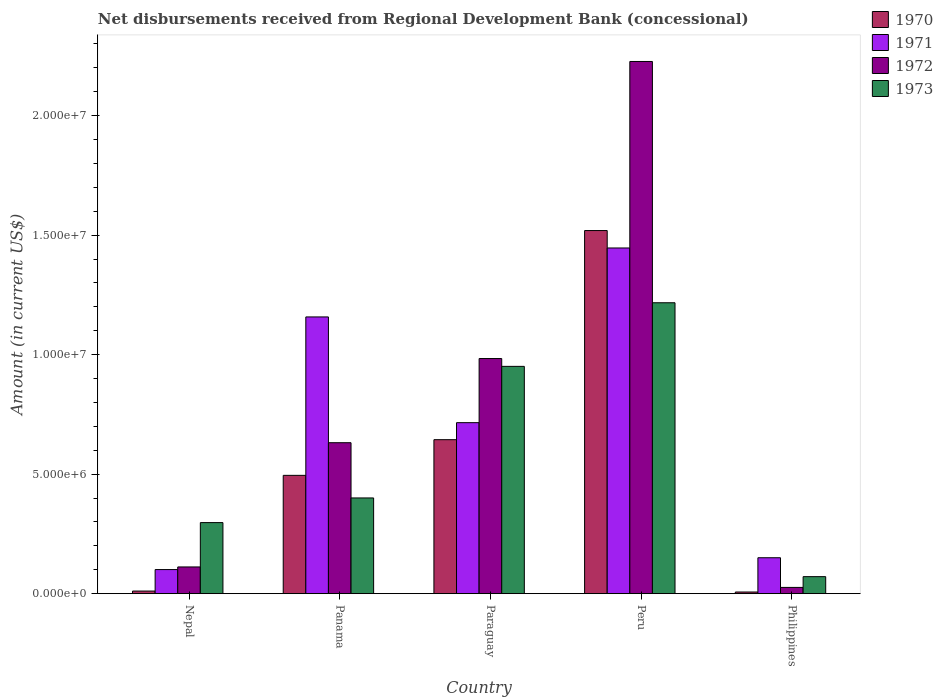Are the number of bars per tick equal to the number of legend labels?
Offer a terse response. Yes. Are the number of bars on each tick of the X-axis equal?
Offer a very short reply. Yes. What is the label of the 4th group of bars from the left?
Your answer should be compact. Peru. In how many cases, is the number of bars for a given country not equal to the number of legend labels?
Your response must be concise. 0. What is the amount of disbursements received from Regional Development Bank in 1972 in Peru?
Your answer should be compact. 2.23e+07. Across all countries, what is the maximum amount of disbursements received from Regional Development Bank in 1973?
Your answer should be compact. 1.22e+07. Across all countries, what is the minimum amount of disbursements received from Regional Development Bank in 1972?
Provide a succinct answer. 2.61e+05. In which country was the amount of disbursements received from Regional Development Bank in 1971 minimum?
Your answer should be compact. Nepal. What is the total amount of disbursements received from Regional Development Bank in 1971 in the graph?
Provide a succinct answer. 3.57e+07. What is the difference between the amount of disbursements received from Regional Development Bank in 1971 in Panama and that in Paraguay?
Keep it short and to the point. 4.42e+06. What is the difference between the amount of disbursements received from Regional Development Bank in 1973 in Philippines and the amount of disbursements received from Regional Development Bank in 1972 in Nepal?
Give a very brief answer. -4.06e+05. What is the average amount of disbursements received from Regional Development Bank in 1972 per country?
Offer a terse response. 7.96e+06. What is the difference between the amount of disbursements received from Regional Development Bank of/in 1972 and amount of disbursements received from Regional Development Bank of/in 1970 in Nepal?
Your response must be concise. 1.01e+06. What is the ratio of the amount of disbursements received from Regional Development Bank in 1972 in Nepal to that in Panama?
Provide a short and direct response. 0.18. Is the amount of disbursements received from Regional Development Bank in 1972 in Paraguay less than that in Philippines?
Provide a succinct answer. No. What is the difference between the highest and the second highest amount of disbursements received from Regional Development Bank in 1973?
Make the answer very short. 2.66e+06. What is the difference between the highest and the lowest amount of disbursements received from Regional Development Bank in 1972?
Your answer should be very brief. 2.20e+07. In how many countries, is the amount of disbursements received from Regional Development Bank in 1970 greater than the average amount of disbursements received from Regional Development Bank in 1970 taken over all countries?
Provide a short and direct response. 2. Is the sum of the amount of disbursements received from Regional Development Bank in 1971 in Peru and Philippines greater than the maximum amount of disbursements received from Regional Development Bank in 1972 across all countries?
Offer a very short reply. No. Is it the case that in every country, the sum of the amount of disbursements received from Regional Development Bank in 1973 and amount of disbursements received from Regional Development Bank in 1972 is greater than the amount of disbursements received from Regional Development Bank in 1971?
Keep it short and to the point. No. How many bars are there?
Offer a very short reply. 20. How many countries are there in the graph?
Give a very brief answer. 5. What is the difference between two consecutive major ticks on the Y-axis?
Your response must be concise. 5.00e+06. Are the values on the major ticks of Y-axis written in scientific E-notation?
Ensure brevity in your answer.  Yes. Does the graph contain any zero values?
Offer a very short reply. No. Does the graph contain grids?
Make the answer very short. No. What is the title of the graph?
Give a very brief answer. Net disbursements received from Regional Development Bank (concessional). What is the Amount (in current US$) of 1970 in Nepal?
Give a very brief answer. 1.09e+05. What is the Amount (in current US$) in 1971 in Nepal?
Your answer should be compact. 1.01e+06. What is the Amount (in current US$) in 1972 in Nepal?
Ensure brevity in your answer.  1.12e+06. What is the Amount (in current US$) in 1973 in Nepal?
Your answer should be compact. 2.97e+06. What is the Amount (in current US$) in 1970 in Panama?
Your response must be concise. 4.95e+06. What is the Amount (in current US$) of 1971 in Panama?
Offer a terse response. 1.16e+07. What is the Amount (in current US$) in 1972 in Panama?
Offer a terse response. 6.32e+06. What is the Amount (in current US$) of 1973 in Panama?
Offer a terse response. 4.00e+06. What is the Amount (in current US$) in 1970 in Paraguay?
Your answer should be very brief. 6.44e+06. What is the Amount (in current US$) in 1971 in Paraguay?
Provide a short and direct response. 7.16e+06. What is the Amount (in current US$) of 1972 in Paraguay?
Ensure brevity in your answer.  9.84e+06. What is the Amount (in current US$) of 1973 in Paraguay?
Offer a very short reply. 9.51e+06. What is the Amount (in current US$) in 1970 in Peru?
Give a very brief answer. 1.52e+07. What is the Amount (in current US$) in 1971 in Peru?
Your answer should be very brief. 1.45e+07. What is the Amount (in current US$) in 1972 in Peru?
Provide a short and direct response. 2.23e+07. What is the Amount (in current US$) in 1973 in Peru?
Keep it short and to the point. 1.22e+07. What is the Amount (in current US$) of 1970 in Philippines?
Keep it short and to the point. 6.90e+04. What is the Amount (in current US$) in 1971 in Philippines?
Provide a succinct answer. 1.50e+06. What is the Amount (in current US$) of 1972 in Philippines?
Ensure brevity in your answer.  2.61e+05. What is the Amount (in current US$) of 1973 in Philippines?
Your response must be concise. 7.12e+05. Across all countries, what is the maximum Amount (in current US$) of 1970?
Your response must be concise. 1.52e+07. Across all countries, what is the maximum Amount (in current US$) in 1971?
Keep it short and to the point. 1.45e+07. Across all countries, what is the maximum Amount (in current US$) in 1972?
Offer a terse response. 2.23e+07. Across all countries, what is the maximum Amount (in current US$) in 1973?
Provide a succinct answer. 1.22e+07. Across all countries, what is the minimum Amount (in current US$) in 1970?
Your response must be concise. 6.90e+04. Across all countries, what is the minimum Amount (in current US$) in 1971?
Your answer should be very brief. 1.01e+06. Across all countries, what is the minimum Amount (in current US$) of 1972?
Your answer should be compact. 2.61e+05. Across all countries, what is the minimum Amount (in current US$) of 1973?
Keep it short and to the point. 7.12e+05. What is the total Amount (in current US$) in 1970 in the graph?
Provide a succinct answer. 2.68e+07. What is the total Amount (in current US$) in 1971 in the graph?
Provide a short and direct response. 3.57e+07. What is the total Amount (in current US$) in 1972 in the graph?
Keep it short and to the point. 3.98e+07. What is the total Amount (in current US$) of 1973 in the graph?
Provide a succinct answer. 2.94e+07. What is the difference between the Amount (in current US$) of 1970 in Nepal and that in Panama?
Your answer should be compact. -4.84e+06. What is the difference between the Amount (in current US$) of 1971 in Nepal and that in Panama?
Provide a short and direct response. -1.06e+07. What is the difference between the Amount (in current US$) of 1972 in Nepal and that in Panama?
Offer a very short reply. -5.20e+06. What is the difference between the Amount (in current US$) in 1973 in Nepal and that in Panama?
Give a very brief answer. -1.03e+06. What is the difference between the Amount (in current US$) of 1970 in Nepal and that in Paraguay?
Your answer should be very brief. -6.33e+06. What is the difference between the Amount (in current US$) in 1971 in Nepal and that in Paraguay?
Provide a short and direct response. -6.15e+06. What is the difference between the Amount (in current US$) of 1972 in Nepal and that in Paraguay?
Offer a terse response. -8.72e+06. What is the difference between the Amount (in current US$) of 1973 in Nepal and that in Paraguay?
Provide a succinct answer. -6.54e+06. What is the difference between the Amount (in current US$) of 1970 in Nepal and that in Peru?
Provide a succinct answer. -1.51e+07. What is the difference between the Amount (in current US$) of 1971 in Nepal and that in Peru?
Your response must be concise. -1.35e+07. What is the difference between the Amount (in current US$) in 1972 in Nepal and that in Peru?
Your answer should be compact. -2.11e+07. What is the difference between the Amount (in current US$) of 1973 in Nepal and that in Peru?
Provide a succinct answer. -9.20e+06. What is the difference between the Amount (in current US$) of 1970 in Nepal and that in Philippines?
Your answer should be very brief. 4.00e+04. What is the difference between the Amount (in current US$) in 1971 in Nepal and that in Philippines?
Provide a short and direct response. -4.95e+05. What is the difference between the Amount (in current US$) in 1972 in Nepal and that in Philippines?
Your answer should be very brief. 8.57e+05. What is the difference between the Amount (in current US$) of 1973 in Nepal and that in Philippines?
Keep it short and to the point. 2.26e+06. What is the difference between the Amount (in current US$) of 1970 in Panama and that in Paraguay?
Your answer should be compact. -1.49e+06. What is the difference between the Amount (in current US$) in 1971 in Panama and that in Paraguay?
Keep it short and to the point. 4.42e+06. What is the difference between the Amount (in current US$) of 1972 in Panama and that in Paraguay?
Your response must be concise. -3.52e+06. What is the difference between the Amount (in current US$) of 1973 in Panama and that in Paraguay?
Keep it short and to the point. -5.50e+06. What is the difference between the Amount (in current US$) of 1970 in Panama and that in Peru?
Offer a very short reply. -1.02e+07. What is the difference between the Amount (in current US$) of 1971 in Panama and that in Peru?
Give a very brief answer. -2.88e+06. What is the difference between the Amount (in current US$) in 1972 in Panama and that in Peru?
Your response must be concise. -1.60e+07. What is the difference between the Amount (in current US$) of 1973 in Panama and that in Peru?
Your answer should be very brief. -8.17e+06. What is the difference between the Amount (in current US$) in 1970 in Panama and that in Philippines?
Provide a short and direct response. 4.88e+06. What is the difference between the Amount (in current US$) in 1971 in Panama and that in Philippines?
Give a very brief answer. 1.01e+07. What is the difference between the Amount (in current US$) in 1972 in Panama and that in Philippines?
Offer a terse response. 6.06e+06. What is the difference between the Amount (in current US$) in 1973 in Panama and that in Philippines?
Your response must be concise. 3.29e+06. What is the difference between the Amount (in current US$) of 1970 in Paraguay and that in Peru?
Ensure brevity in your answer.  -8.75e+06. What is the difference between the Amount (in current US$) of 1971 in Paraguay and that in Peru?
Offer a terse response. -7.31e+06. What is the difference between the Amount (in current US$) of 1972 in Paraguay and that in Peru?
Make the answer very short. -1.24e+07. What is the difference between the Amount (in current US$) in 1973 in Paraguay and that in Peru?
Keep it short and to the point. -2.66e+06. What is the difference between the Amount (in current US$) of 1970 in Paraguay and that in Philippines?
Your response must be concise. 6.37e+06. What is the difference between the Amount (in current US$) of 1971 in Paraguay and that in Philippines?
Provide a short and direct response. 5.65e+06. What is the difference between the Amount (in current US$) of 1972 in Paraguay and that in Philippines?
Provide a succinct answer. 9.58e+06. What is the difference between the Amount (in current US$) in 1973 in Paraguay and that in Philippines?
Your answer should be very brief. 8.80e+06. What is the difference between the Amount (in current US$) of 1970 in Peru and that in Philippines?
Ensure brevity in your answer.  1.51e+07. What is the difference between the Amount (in current US$) in 1971 in Peru and that in Philippines?
Provide a short and direct response. 1.30e+07. What is the difference between the Amount (in current US$) of 1972 in Peru and that in Philippines?
Make the answer very short. 2.20e+07. What is the difference between the Amount (in current US$) in 1973 in Peru and that in Philippines?
Your answer should be very brief. 1.15e+07. What is the difference between the Amount (in current US$) in 1970 in Nepal and the Amount (in current US$) in 1971 in Panama?
Give a very brief answer. -1.15e+07. What is the difference between the Amount (in current US$) in 1970 in Nepal and the Amount (in current US$) in 1972 in Panama?
Your answer should be compact. -6.21e+06. What is the difference between the Amount (in current US$) in 1970 in Nepal and the Amount (in current US$) in 1973 in Panama?
Your answer should be compact. -3.90e+06. What is the difference between the Amount (in current US$) of 1971 in Nepal and the Amount (in current US$) of 1972 in Panama?
Give a very brief answer. -5.31e+06. What is the difference between the Amount (in current US$) in 1971 in Nepal and the Amount (in current US$) in 1973 in Panama?
Ensure brevity in your answer.  -3.00e+06. What is the difference between the Amount (in current US$) of 1972 in Nepal and the Amount (in current US$) of 1973 in Panama?
Give a very brief answer. -2.89e+06. What is the difference between the Amount (in current US$) of 1970 in Nepal and the Amount (in current US$) of 1971 in Paraguay?
Offer a very short reply. -7.05e+06. What is the difference between the Amount (in current US$) of 1970 in Nepal and the Amount (in current US$) of 1972 in Paraguay?
Provide a short and direct response. -9.73e+06. What is the difference between the Amount (in current US$) in 1970 in Nepal and the Amount (in current US$) in 1973 in Paraguay?
Your answer should be compact. -9.40e+06. What is the difference between the Amount (in current US$) in 1971 in Nepal and the Amount (in current US$) in 1972 in Paraguay?
Keep it short and to the point. -8.83e+06. What is the difference between the Amount (in current US$) of 1971 in Nepal and the Amount (in current US$) of 1973 in Paraguay?
Your answer should be very brief. -8.50e+06. What is the difference between the Amount (in current US$) in 1972 in Nepal and the Amount (in current US$) in 1973 in Paraguay?
Offer a very short reply. -8.39e+06. What is the difference between the Amount (in current US$) in 1970 in Nepal and the Amount (in current US$) in 1971 in Peru?
Provide a short and direct response. -1.44e+07. What is the difference between the Amount (in current US$) in 1970 in Nepal and the Amount (in current US$) in 1972 in Peru?
Your answer should be very brief. -2.22e+07. What is the difference between the Amount (in current US$) in 1970 in Nepal and the Amount (in current US$) in 1973 in Peru?
Make the answer very short. -1.21e+07. What is the difference between the Amount (in current US$) of 1971 in Nepal and the Amount (in current US$) of 1972 in Peru?
Ensure brevity in your answer.  -2.13e+07. What is the difference between the Amount (in current US$) of 1971 in Nepal and the Amount (in current US$) of 1973 in Peru?
Ensure brevity in your answer.  -1.12e+07. What is the difference between the Amount (in current US$) in 1972 in Nepal and the Amount (in current US$) in 1973 in Peru?
Your response must be concise. -1.11e+07. What is the difference between the Amount (in current US$) of 1970 in Nepal and the Amount (in current US$) of 1971 in Philippines?
Your response must be concise. -1.39e+06. What is the difference between the Amount (in current US$) of 1970 in Nepal and the Amount (in current US$) of 1972 in Philippines?
Keep it short and to the point. -1.52e+05. What is the difference between the Amount (in current US$) in 1970 in Nepal and the Amount (in current US$) in 1973 in Philippines?
Keep it short and to the point. -6.03e+05. What is the difference between the Amount (in current US$) in 1971 in Nepal and the Amount (in current US$) in 1972 in Philippines?
Give a very brief answer. 7.47e+05. What is the difference between the Amount (in current US$) in 1971 in Nepal and the Amount (in current US$) in 1973 in Philippines?
Offer a very short reply. 2.96e+05. What is the difference between the Amount (in current US$) in 1972 in Nepal and the Amount (in current US$) in 1973 in Philippines?
Your response must be concise. 4.06e+05. What is the difference between the Amount (in current US$) in 1970 in Panama and the Amount (in current US$) in 1971 in Paraguay?
Give a very brief answer. -2.20e+06. What is the difference between the Amount (in current US$) in 1970 in Panama and the Amount (in current US$) in 1972 in Paraguay?
Your response must be concise. -4.89e+06. What is the difference between the Amount (in current US$) in 1970 in Panama and the Amount (in current US$) in 1973 in Paraguay?
Offer a very short reply. -4.56e+06. What is the difference between the Amount (in current US$) in 1971 in Panama and the Amount (in current US$) in 1972 in Paraguay?
Your answer should be compact. 1.74e+06. What is the difference between the Amount (in current US$) in 1971 in Panama and the Amount (in current US$) in 1973 in Paraguay?
Offer a terse response. 2.07e+06. What is the difference between the Amount (in current US$) of 1972 in Panama and the Amount (in current US$) of 1973 in Paraguay?
Offer a very short reply. -3.19e+06. What is the difference between the Amount (in current US$) in 1970 in Panama and the Amount (in current US$) in 1971 in Peru?
Provide a succinct answer. -9.51e+06. What is the difference between the Amount (in current US$) in 1970 in Panama and the Amount (in current US$) in 1972 in Peru?
Your answer should be compact. -1.73e+07. What is the difference between the Amount (in current US$) of 1970 in Panama and the Amount (in current US$) of 1973 in Peru?
Make the answer very short. -7.22e+06. What is the difference between the Amount (in current US$) of 1971 in Panama and the Amount (in current US$) of 1972 in Peru?
Make the answer very short. -1.07e+07. What is the difference between the Amount (in current US$) of 1971 in Panama and the Amount (in current US$) of 1973 in Peru?
Your answer should be compact. -5.93e+05. What is the difference between the Amount (in current US$) in 1972 in Panama and the Amount (in current US$) in 1973 in Peru?
Keep it short and to the point. -5.86e+06. What is the difference between the Amount (in current US$) of 1970 in Panama and the Amount (in current US$) of 1971 in Philippines?
Give a very brief answer. 3.45e+06. What is the difference between the Amount (in current US$) in 1970 in Panama and the Amount (in current US$) in 1972 in Philippines?
Give a very brief answer. 4.69e+06. What is the difference between the Amount (in current US$) in 1970 in Panama and the Amount (in current US$) in 1973 in Philippines?
Offer a very short reply. 4.24e+06. What is the difference between the Amount (in current US$) of 1971 in Panama and the Amount (in current US$) of 1972 in Philippines?
Keep it short and to the point. 1.13e+07. What is the difference between the Amount (in current US$) in 1971 in Panama and the Amount (in current US$) in 1973 in Philippines?
Ensure brevity in your answer.  1.09e+07. What is the difference between the Amount (in current US$) in 1972 in Panama and the Amount (in current US$) in 1973 in Philippines?
Give a very brief answer. 5.60e+06. What is the difference between the Amount (in current US$) of 1970 in Paraguay and the Amount (in current US$) of 1971 in Peru?
Provide a short and direct response. -8.02e+06. What is the difference between the Amount (in current US$) in 1970 in Paraguay and the Amount (in current US$) in 1972 in Peru?
Keep it short and to the point. -1.58e+07. What is the difference between the Amount (in current US$) in 1970 in Paraguay and the Amount (in current US$) in 1973 in Peru?
Your answer should be compact. -5.73e+06. What is the difference between the Amount (in current US$) of 1971 in Paraguay and the Amount (in current US$) of 1972 in Peru?
Keep it short and to the point. -1.51e+07. What is the difference between the Amount (in current US$) in 1971 in Paraguay and the Amount (in current US$) in 1973 in Peru?
Your answer should be compact. -5.02e+06. What is the difference between the Amount (in current US$) of 1972 in Paraguay and the Amount (in current US$) of 1973 in Peru?
Keep it short and to the point. -2.33e+06. What is the difference between the Amount (in current US$) in 1970 in Paraguay and the Amount (in current US$) in 1971 in Philippines?
Give a very brief answer. 4.94e+06. What is the difference between the Amount (in current US$) of 1970 in Paraguay and the Amount (in current US$) of 1972 in Philippines?
Give a very brief answer. 6.18e+06. What is the difference between the Amount (in current US$) of 1970 in Paraguay and the Amount (in current US$) of 1973 in Philippines?
Your response must be concise. 5.73e+06. What is the difference between the Amount (in current US$) of 1971 in Paraguay and the Amount (in current US$) of 1972 in Philippines?
Ensure brevity in your answer.  6.89e+06. What is the difference between the Amount (in current US$) in 1971 in Paraguay and the Amount (in current US$) in 1973 in Philippines?
Give a very brief answer. 6.44e+06. What is the difference between the Amount (in current US$) of 1972 in Paraguay and the Amount (in current US$) of 1973 in Philippines?
Ensure brevity in your answer.  9.13e+06. What is the difference between the Amount (in current US$) of 1970 in Peru and the Amount (in current US$) of 1971 in Philippines?
Your response must be concise. 1.37e+07. What is the difference between the Amount (in current US$) in 1970 in Peru and the Amount (in current US$) in 1972 in Philippines?
Provide a short and direct response. 1.49e+07. What is the difference between the Amount (in current US$) of 1970 in Peru and the Amount (in current US$) of 1973 in Philippines?
Give a very brief answer. 1.45e+07. What is the difference between the Amount (in current US$) of 1971 in Peru and the Amount (in current US$) of 1972 in Philippines?
Provide a succinct answer. 1.42e+07. What is the difference between the Amount (in current US$) of 1971 in Peru and the Amount (in current US$) of 1973 in Philippines?
Keep it short and to the point. 1.38e+07. What is the difference between the Amount (in current US$) in 1972 in Peru and the Amount (in current US$) in 1973 in Philippines?
Your answer should be very brief. 2.16e+07. What is the average Amount (in current US$) in 1970 per country?
Offer a very short reply. 5.35e+06. What is the average Amount (in current US$) of 1971 per country?
Offer a very short reply. 7.14e+06. What is the average Amount (in current US$) in 1972 per country?
Provide a short and direct response. 7.96e+06. What is the average Amount (in current US$) of 1973 per country?
Your response must be concise. 5.87e+06. What is the difference between the Amount (in current US$) of 1970 and Amount (in current US$) of 1971 in Nepal?
Provide a short and direct response. -8.99e+05. What is the difference between the Amount (in current US$) of 1970 and Amount (in current US$) of 1972 in Nepal?
Make the answer very short. -1.01e+06. What is the difference between the Amount (in current US$) in 1970 and Amount (in current US$) in 1973 in Nepal?
Give a very brief answer. -2.86e+06. What is the difference between the Amount (in current US$) in 1971 and Amount (in current US$) in 1973 in Nepal?
Make the answer very short. -1.96e+06. What is the difference between the Amount (in current US$) in 1972 and Amount (in current US$) in 1973 in Nepal?
Provide a succinct answer. -1.86e+06. What is the difference between the Amount (in current US$) in 1970 and Amount (in current US$) in 1971 in Panama?
Offer a very short reply. -6.63e+06. What is the difference between the Amount (in current US$) of 1970 and Amount (in current US$) of 1972 in Panama?
Keep it short and to the point. -1.37e+06. What is the difference between the Amount (in current US$) in 1970 and Amount (in current US$) in 1973 in Panama?
Ensure brevity in your answer.  9.45e+05. What is the difference between the Amount (in current US$) of 1971 and Amount (in current US$) of 1972 in Panama?
Ensure brevity in your answer.  5.26e+06. What is the difference between the Amount (in current US$) of 1971 and Amount (in current US$) of 1973 in Panama?
Provide a succinct answer. 7.57e+06. What is the difference between the Amount (in current US$) of 1972 and Amount (in current US$) of 1973 in Panama?
Offer a very short reply. 2.31e+06. What is the difference between the Amount (in current US$) in 1970 and Amount (in current US$) in 1971 in Paraguay?
Provide a succinct answer. -7.12e+05. What is the difference between the Amount (in current US$) of 1970 and Amount (in current US$) of 1972 in Paraguay?
Ensure brevity in your answer.  -3.40e+06. What is the difference between the Amount (in current US$) in 1970 and Amount (in current US$) in 1973 in Paraguay?
Provide a succinct answer. -3.07e+06. What is the difference between the Amount (in current US$) in 1971 and Amount (in current US$) in 1972 in Paraguay?
Ensure brevity in your answer.  -2.68e+06. What is the difference between the Amount (in current US$) in 1971 and Amount (in current US$) in 1973 in Paraguay?
Make the answer very short. -2.36e+06. What is the difference between the Amount (in current US$) in 1972 and Amount (in current US$) in 1973 in Paraguay?
Make the answer very short. 3.28e+05. What is the difference between the Amount (in current US$) in 1970 and Amount (in current US$) in 1971 in Peru?
Make the answer very short. 7.29e+05. What is the difference between the Amount (in current US$) of 1970 and Amount (in current US$) of 1972 in Peru?
Ensure brevity in your answer.  -7.07e+06. What is the difference between the Amount (in current US$) in 1970 and Amount (in current US$) in 1973 in Peru?
Provide a succinct answer. 3.02e+06. What is the difference between the Amount (in current US$) of 1971 and Amount (in current US$) of 1972 in Peru?
Offer a very short reply. -7.80e+06. What is the difference between the Amount (in current US$) in 1971 and Amount (in current US$) in 1973 in Peru?
Give a very brief answer. 2.29e+06. What is the difference between the Amount (in current US$) in 1972 and Amount (in current US$) in 1973 in Peru?
Your answer should be compact. 1.01e+07. What is the difference between the Amount (in current US$) of 1970 and Amount (in current US$) of 1971 in Philippines?
Provide a short and direct response. -1.43e+06. What is the difference between the Amount (in current US$) of 1970 and Amount (in current US$) of 1972 in Philippines?
Provide a succinct answer. -1.92e+05. What is the difference between the Amount (in current US$) in 1970 and Amount (in current US$) in 1973 in Philippines?
Ensure brevity in your answer.  -6.43e+05. What is the difference between the Amount (in current US$) in 1971 and Amount (in current US$) in 1972 in Philippines?
Offer a terse response. 1.24e+06. What is the difference between the Amount (in current US$) in 1971 and Amount (in current US$) in 1973 in Philippines?
Your response must be concise. 7.91e+05. What is the difference between the Amount (in current US$) of 1972 and Amount (in current US$) of 1973 in Philippines?
Keep it short and to the point. -4.51e+05. What is the ratio of the Amount (in current US$) in 1970 in Nepal to that in Panama?
Your answer should be compact. 0.02. What is the ratio of the Amount (in current US$) in 1971 in Nepal to that in Panama?
Give a very brief answer. 0.09. What is the ratio of the Amount (in current US$) in 1972 in Nepal to that in Panama?
Provide a short and direct response. 0.18. What is the ratio of the Amount (in current US$) of 1973 in Nepal to that in Panama?
Your response must be concise. 0.74. What is the ratio of the Amount (in current US$) in 1970 in Nepal to that in Paraguay?
Ensure brevity in your answer.  0.02. What is the ratio of the Amount (in current US$) in 1971 in Nepal to that in Paraguay?
Your answer should be very brief. 0.14. What is the ratio of the Amount (in current US$) in 1972 in Nepal to that in Paraguay?
Ensure brevity in your answer.  0.11. What is the ratio of the Amount (in current US$) in 1973 in Nepal to that in Paraguay?
Offer a terse response. 0.31. What is the ratio of the Amount (in current US$) of 1970 in Nepal to that in Peru?
Keep it short and to the point. 0.01. What is the ratio of the Amount (in current US$) of 1971 in Nepal to that in Peru?
Make the answer very short. 0.07. What is the ratio of the Amount (in current US$) in 1972 in Nepal to that in Peru?
Offer a very short reply. 0.05. What is the ratio of the Amount (in current US$) of 1973 in Nepal to that in Peru?
Keep it short and to the point. 0.24. What is the ratio of the Amount (in current US$) in 1970 in Nepal to that in Philippines?
Your response must be concise. 1.58. What is the ratio of the Amount (in current US$) in 1971 in Nepal to that in Philippines?
Your answer should be compact. 0.67. What is the ratio of the Amount (in current US$) in 1972 in Nepal to that in Philippines?
Your response must be concise. 4.28. What is the ratio of the Amount (in current US$) of 1973 in Nepal to that in Philippines?
Offer a very short reply. 4.18. What is the ratio of the Amount (in current US$) of 1970 in Panama to that in Paraguay?
Your answer should be very brief. 0.77. What is the ratio of the Amount (in current US$) in 1971 in Panama to that in Paraguay?
Provide a short and direct response. 1.62. What is the ratio of the Amount (in current US$) in 1972 in Panama to that in Paraguay?
Your answer should be compact. 0.64. What is the ratio of the Amount (in current US$) of 1973 in Panama to that in Paraguay?
Your response must be concise. 0.42. What is the ratio of the Amount (in current US$) in 1970 in Panama to that in Peru?
Your response must be concise. 0.33. What is the ratio of the Amount (in current US$) of 1971 in Panama to that in Peru?
Your response must be concise. 0.8. What is the ratio of the Amount (in current US$) in 1972 in Panama to that in Peru?
Your answer should be compact. 0.28. What is the ratio of the Amount (in current US$) of 1973 in Panama to that in Peru?
Keep it short and to the point. 0.33. What is the ratio of the Amount (in current US$) of 1970 in Panama to that in Philippines?
Your answer should be very brief. 71.74. What is the ratio of the Amount (in current US$) in 1971 in Panama to that in Philippines?
Give a very brief answer. 7.7. What is the ratio of the Amount (in current US$) of 1972 in Panama to that in Philippines?
Offer a very short reply. 24.2. What is the ratio of the Amount (in current US$) in 1973 in Panama to that in Philippines?
Your response must be concise. 5.62. What is the ratio of the Amount (in current US$) of 1970 in Paraguay to that in Peru?
Give a very brief answer. 0.42. What is the ratio of the Amount (in current US$) of 1971 in Paraguay to that in Peru?
Ensure brevity in your answer.  0.49. What is the ratio of the Amount (in current US$) of 1972 in Paraguay to that in Peru?
Keep it short and to the point. 0.44. What is the ratio of the Amount (in current US$) of 1973 in Paraguay to that in Peru?
Your answer should be very brief. 0.78. What is the ratio of the Amount (in current US$) of 1970 in Paraguay to that in Philippines?
Ensure brevity in your answer.  93.38. What is the ratio of the Amount (in current US$) in 1971 in Paraguay to that in Philippines?
Offer a very short reply. 4.76. What is the ratio of the Amount (in current US$) of 1972 in Paraguay to that in Philippines?
Your answer should be very brief. 37.69. What is the ratio of the Amount (in current US$) in 1973 in Paraguay to that in Philippines?
Your response must be concise. 13.36. What is the ratio of the Amount (in current US$) of 1970 in Peru to that in Philippines?
Keep it short and to the point. 220.19. What is the ratio of the Amount (in current US$) in 1971 in Peru to that in Philippines?
Offer a very short reply. 9.62. What is the ratio of the Amount (in current US$) of 1972 in Peru to that in Philippines?
Make the answer very short. 85.31. What is the ratio of the Amount (in current US$) of 1973 in Peru to that in Philippines?
Keep it short and to the point. 17.1. What is the difference between the highest and the second highest Amount (in current US$) in 1970?
Offer a very short reply. 8.75e+06. What is the difference between the highest and the second highest Amount (in current US$) in 1971?
Make the answer very short. 2.88e+06. What is the difference between the highest and the second highest Amount (in current US$) in 1972?
Your answer should be compact. 1.24e+07. What is the difference between the highest and the second highest Amount (in current US$) in 1973?
Your answer should be compact. 2.66e+06. What is the difference between the highest and the lowest Amount (in current US$) in 1970?
Give a very brief answer. 1.51e+07. What is the difference between the highest and the lowest Amount (in current US$) in 1971?
Keep it short and to the point. 1.35e+07. What is the difference between the highest and the lowest Amount (in current US$) in 1972?
Your answer should be compact. 2.20e+07. What is the difference between the highest and the lowest Amount (in current US$) of 1973?
Your answer should be compact. 1.15e+07. 